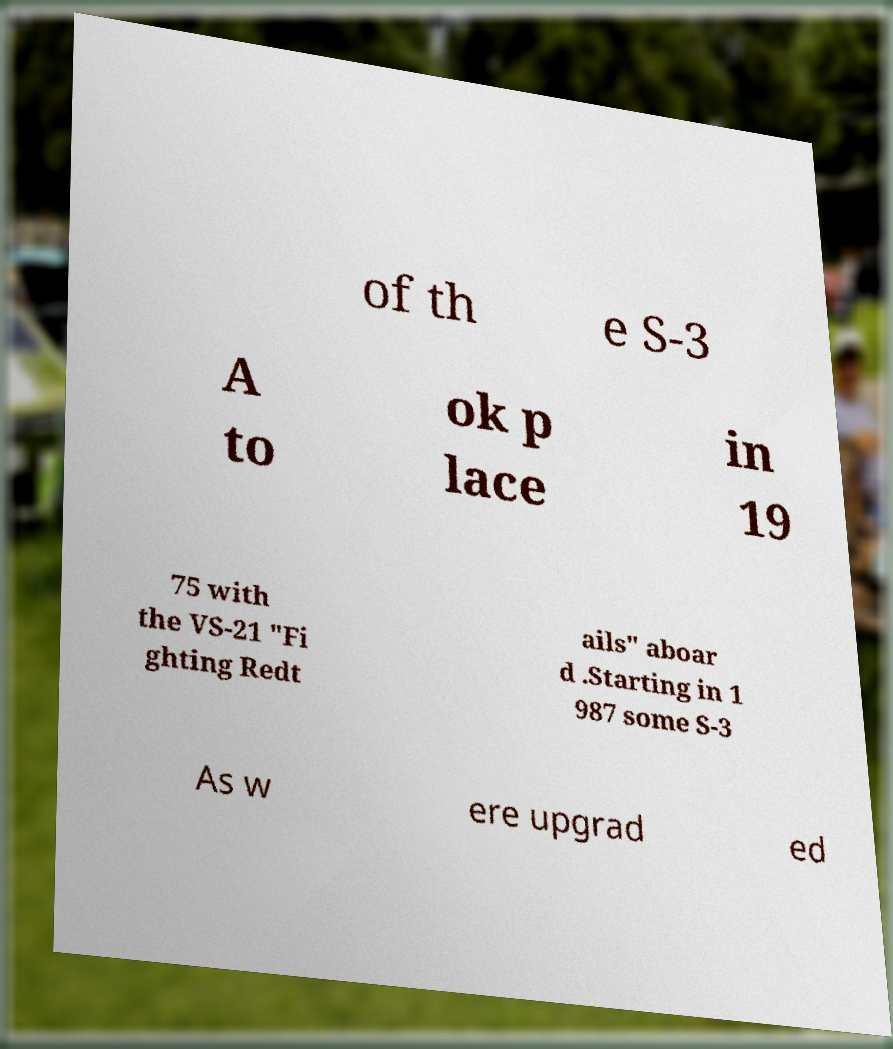Could you assist in decoding the text presented in this image and type it out clearly? of th e S-3 A to ok p lace in 19 75 with the VS-21 "Fi ghting Redt ails" aboar d .Starting in 1 987 some S-3 As w ere upgrad ed 